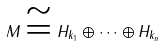<formula> <loc_0><loc_0><loc_500><loc_500>M \cong H _ { k _ { 1 } } \oplus \cdots \oplus H _ { k _ { n } }</formula> 